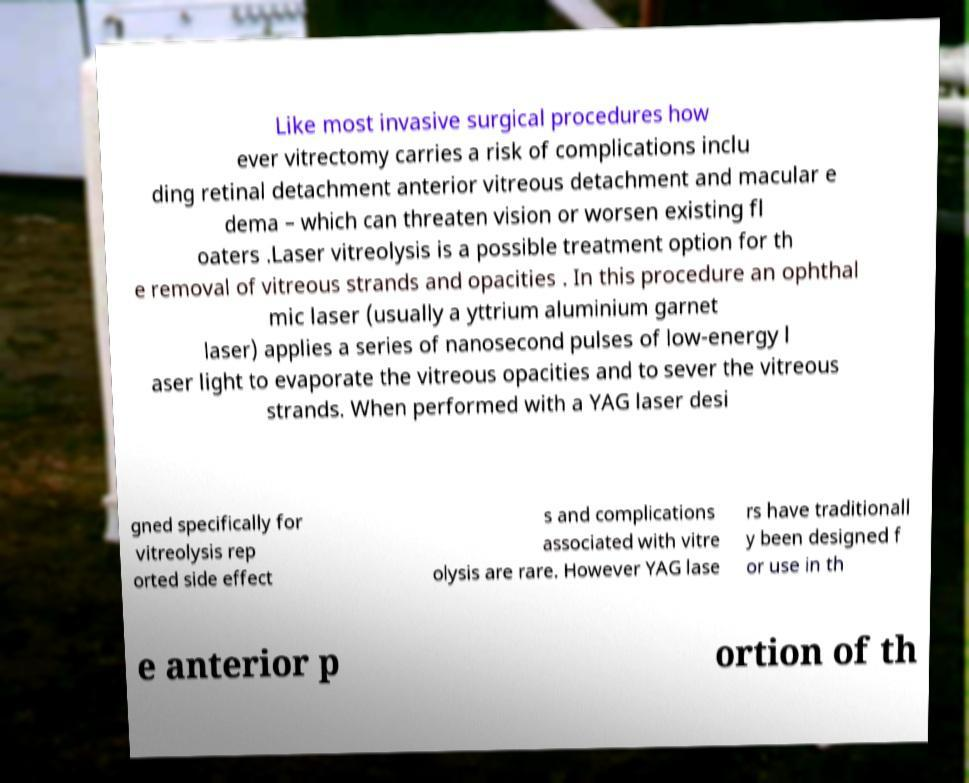Please read and relay the text visible in this image. What does it say? Like most invasive surgical procedures how ever vitrectomy carries a risk of complications inclu ding retinal detachment anterior vitreous detachment and macular e dema – which can threaten vision or worsen existing fl oaters .Laser vitreolysis is a possible treatment option for th e removal of vitreous strands and opacities . In this procedure an ophthal mic laser (usually a yttrium aluminium garnet laser) applies a series of nanosecond pulses of low-energy l aser light to evaporate the vitreous opacities and to sever the vitreous strands. When performed with a YAG laser desi gned specifically for vitreolysis rep orted side effect s and complications associated with vitre olysis are rare. However YAG lase rs have traditionall y been designed f or use in th e anterior p ortion of th 